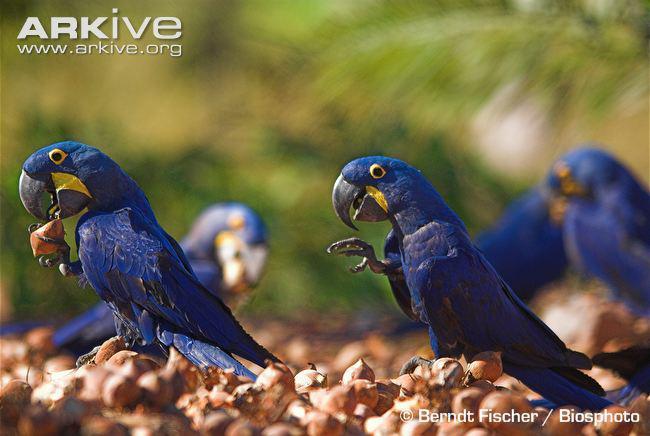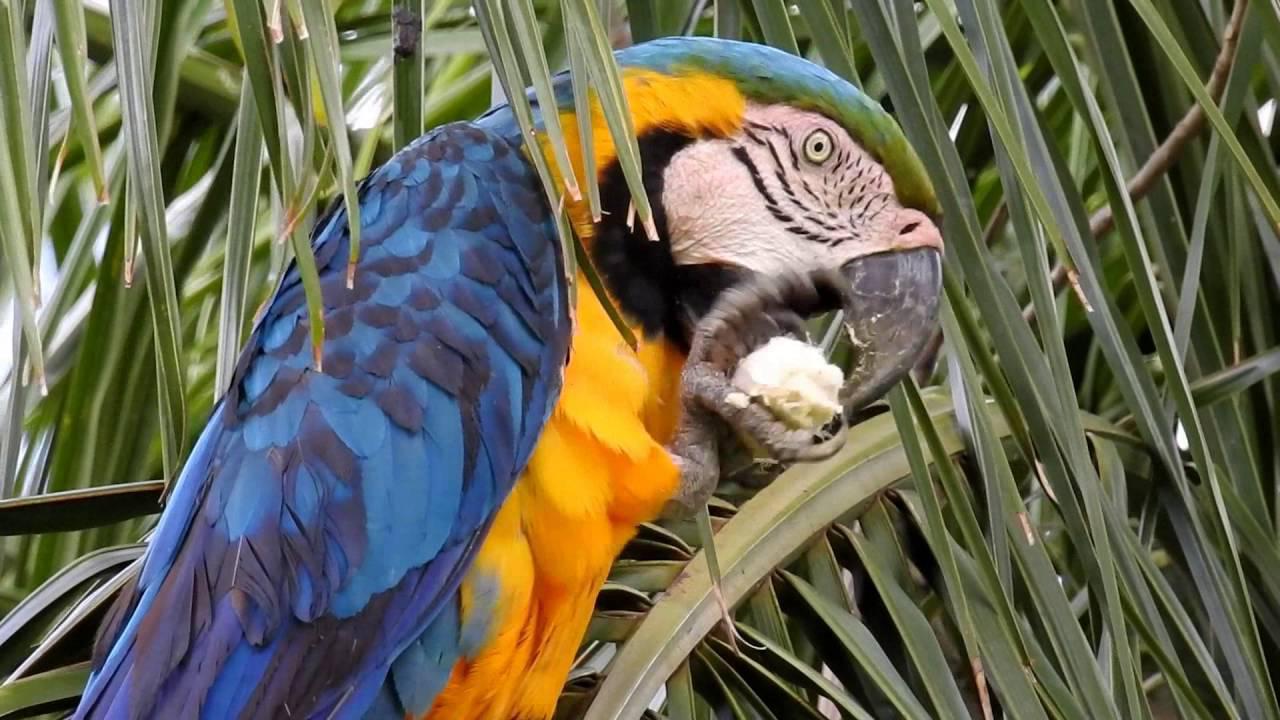The first image is the image on the left, the second image is the image on the right. For the images shown, is this caption "On one image, there's a parrot perched on a branch." true? Answer yes or no. No. The first image is the image on the left, the second image is the image on the right. Considering the images on both sides, is "The birds in both images have predominantly blue and yellow coloring" valid? Answer yes or no. Yes. 